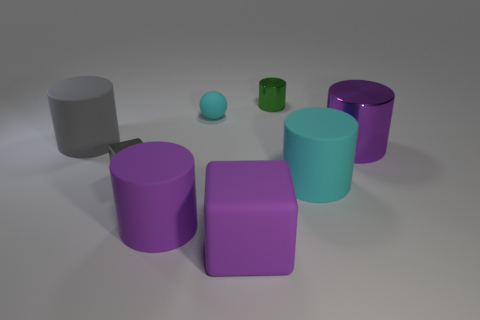Are there any green shiny things that have the same size as the gray metal cube? Yes, there is a small green shiny cylindrical object that appears to closely match the size of the gray cube in the image. 